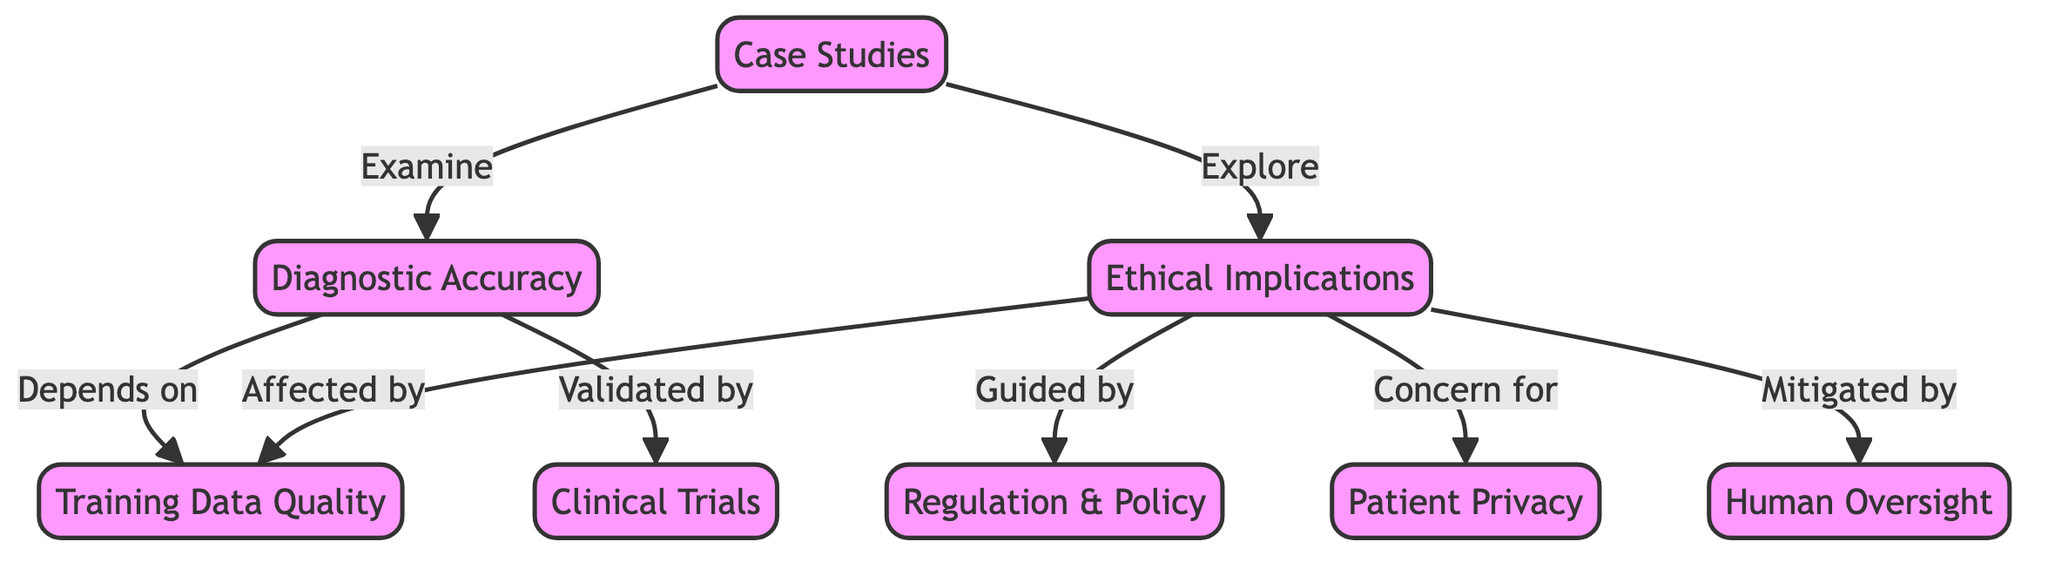What are the two main components shown in the diagram? The diagram clearly identifies two main components: 'Diagnostic Accuracy' and 'Ethical Implications'. Both components are represented as nodes connected to various other elements.
Answer: Diagnostic Accuracy, Ethical Implications How many edges are there in total in the diagram? By counting the lines representing relationships or connections between nodes, we see that there are eight edges connecting these various components.
Answer: 8 What does 'Diagnostic Accuracy' depend on? 'Diagnostic Accuracy' depends on 'Training Data Quality', which is a direct connection represented in the diagram, indicating that the quality of training data is essential for achieving accurate diagnostics.
Answer: Training Data Quality Which node provides guidance to 'Ethical Implications'? The node 'Regulation & Policy' is shown to guide 'Ethical Implications' in the diagram, indicating that regulations play a crucial role in shaping ethical considerations in medical diagnostics.
Answer: Regulation & Policy What aspect is a concern for 'Ethical Implications'? 'Patient Privacy' is indicated as a concern for 'Ethical Implications', emphasizing the importance of safeguarding patient information in the context of medical diagnostics involving AI.
Answer: Patient Privacy Which node is both examining 'Accuracy' and exploring 'Ethical Implications'? 'Case Studies' serves a dual purpose, as it is the node that examines the relationship between 'Accuracy' and explores the aspects of 'Ethical Implications' in the diagram.
Answer: Case Studies What does 'Human Oversight' do to 'Ethical Implications'? 'Human Oversight' is illustrated as a factor that mitigates 'Ethical Implications', suggesting that having human intervention helps alleviate ethical concerns associated with AI in diagnostics.
Answer: Mitigated by How is 'Diagnostic Accuracy' validated? 'Diagnostic Accuracy' is validated by 'Clinical Trials', indicating that undergoing rigorous clinical testing is essential for ensuring that the AI diagnostics are accurate and trustworthy.
Answer: Clinical Trials What is the relationship between 'Training Data Quality' and 'Ethical Implications'? 'Ethical Implications' are affected by 'Training Data Quality', which indicates that the quality of the data used in training AI can have direct implications for ethical concerns in medical diagnostics.
Answer: Affected by 